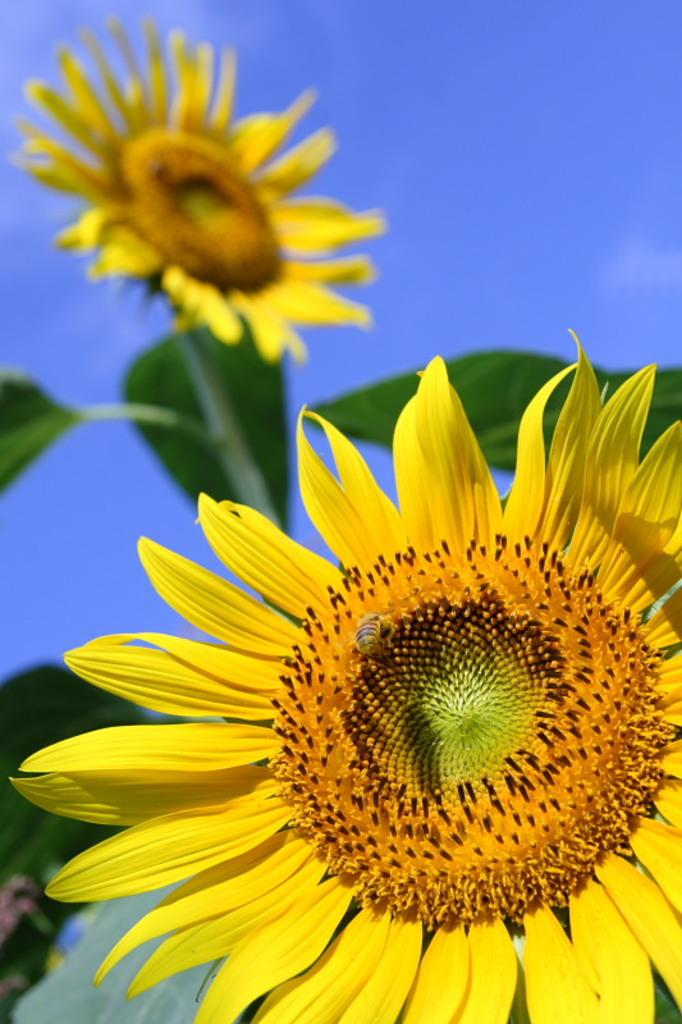How many sunflowers are in the image? There are two sunflowers in the image. What features do the sunflowers have? The sunflowers have leaves. What color is the background of the image? The background of the image appears blue. Can you describe any other living organisms in the image? Yes, there is a small insect on one of the sunflowers. Where is the corn stored in the image? There is no corn present in the image. What type of adjustment can be seen on the sunflowers in the image? There are no adjustments visible on the sunflowers in the image. 